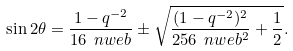Convert formula to latex. <formula><loc_0><loc_0><loc_500><loc_500>\sin 2 \theta = \frac { 1 - q ^ { - 2 } } { 1 6 \ n w e b } \pm \sqrt { \frac { ( 1 - q ^ { - 2 } ) ^ { 2 } } { 2 5 6 \ n w e b ^ { 2 } } + \frac { 1 } { 2 } } .</formula> 